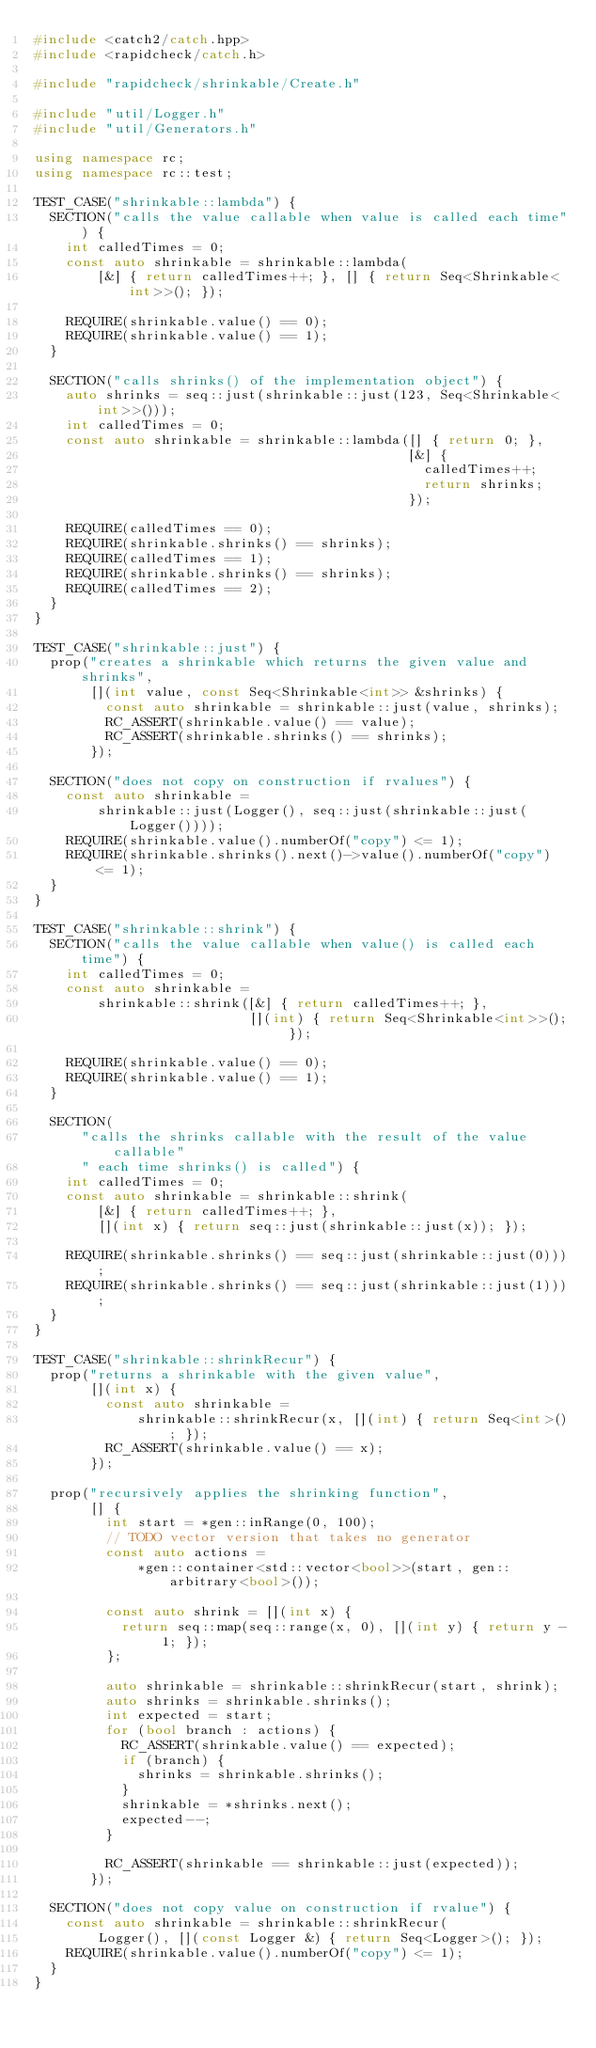<code> <loc_0><loc_0><loc_500><loc_500><_C++_>#include <catch2/catch.hpp>
#include <rapidcheck/catch.h>

#include "rapidcheck/shrinkable/Create.h"

#include "util/Logger.h"
#include "util/Generators.h"

using namespace rc;
using namespace rc::test;

TEST_CASE("shrinkable::lambda") {
  SECTION("calls the value callable when value is called each time") {
    int calledTimes = 0;
    const auto shrinkable = shrinkable::lambda(
        [&] { return calledTimes++; }, [] { return Seq<Shrinkable<int>>(); });

    REQUIRE(shrinkable.value() == 0);
    REQUIRE(shrinkable.value() == 1);
  }

  SECTION("calls shrinks() of the implementation object") {
    auto shrinks = seq::just(shrinkable::just(123, Seq<Shrinkable<int>>()));
    int calledTimes = 0;
    const auto shrinkable = shrinkable::lambda([] { return 0; },
                                               [&] {
                                                 calledTimes++;
                                                 return shrinks;
                                               });

    REQUIRE(calledTimes == 0);
    REQUIRE(shrinkable.shrinks() == shrinks);
    REQUIRE(calledTimes == 1);
    REQUIRE(shrinkable.shrinks() == shrinks);
    REQUIRE(calledTimes == 2);
  }
}

TEST_CASE("shrinkable::just") {
  prop("creates a shrinkable which returns the given value and shrinks",
       [](int value, const Seq<Shrinkable<int>> &shrinks) {
         const auto shrinkable = shrinkable::just(value, shrinks);
         RC_ASSERT(shrinkable.value() == value);
         RC_ASSERT(shrinkable.shrinks() == shrinks);
       });

  SECTION("does not copy on construction if rvalues") {
    const auto shrinkable =
        shrinkable::just(Logger(), seq::just(shrinkable::just(Logger())));
    REQUIRE(shrinkable.value().numberOf("copy") <= 1);
    REQUIRE(shrinkable.shrinks().next()->value().numberOf("copy") <= 1);
  }
}

TEST_CASE("shrinkable::shrink") {
  SECTION("calls the value callable when value() is called each time") {
    int calledTimes = 0;
    const auto shrinkable =
        shrinkable::shrink([&] { return calledTimes++; },
                           [](int) { return Seq<Shrinkable<int>>(); });

    REQUIRE(shrinkable.value() == 0);
    REQUIRE(shrinkable.value() == 1);
  }

  SECTION(
      "calls the shrinks callable with the result of the value callable"
      " each time shrinks() is called") {
    int calledTimes = 0;
    const auto shrinkable = shrinkable::shrink(
        [&] { return calledTimes++; },
        [](int x) { return seq::just(shrinkable::just(x)); });

    REQUIRE(shrinkable.shrinks() == seq::just(shrinkable::just(0)));
    REQUIRE(shrinkable.shrinks() == seq::just(shrinkable::just(1)));
  }
}

TEST_CASE("shrinkable::shrinkRecur") {
  prop("returns a shrinkable with the given value",
       [](int x) {
         const auto shrinkable =
             shrinkable::shrinkRecur(x, [](int) { return Seq<int>(); });
         RC_ASSERT(shrinkable.value() == x);
       });

  prop("recursively applies the shrinking function",
       [] {
         int start = *gen::inRange(0, 100);
         // TODO vector version that takes no generator
         const auto actions =
             *gen::container<std::vector<bool>>(start, gen::arbitrary<bool>());

         const auto shrink = [](int x) {
           return seq::map(seq::range(x, 0), [](int y) { return y - 1; });
         };

         auto shrinkable = shrinkable::shrinkRecur(start, shrink);
         auto shrinks = shrinkable.shrinks();
         int expected = start;
         for (bool branch : actions) {
           RC_ASSERT(shrinkable.value() == expected);
           if (branch) {
             shrinks = shrinkable.shrinks();
           }
           shrinkable = *shrinks.next();
           expected--;
         }

         RC_ASSERT(shrinkable == shrinkable::just(expected));
       });

  SECTION("does not copy value on construction if rvalue") {
    const auto shrinkable = shrinkable::shrinkRecur(
        Logger(), [](const Logger &) { return Seq<Logger>(); });
    REQUIRE(shrinkable.value().numberOf("copy") <= 1);
  }
}
</code> 